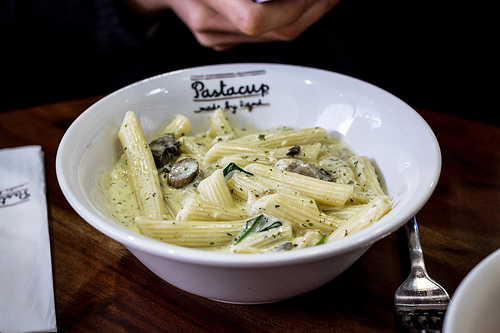<image>
Can you confirm if the fork is under the bowl? Yes. The fork is positioned underneath the bowl, with the bowl above it in the vertical space. 